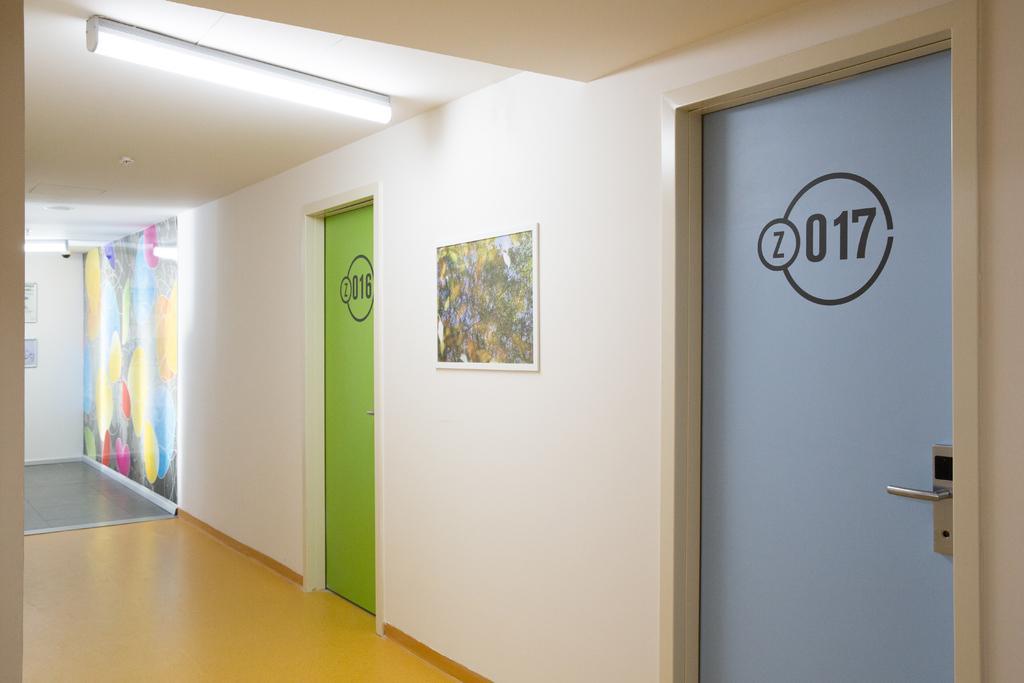In one or two sentences, can you explain what this image depicts? As we can see in the image there is white color wall, doors, photo frame and lights. 